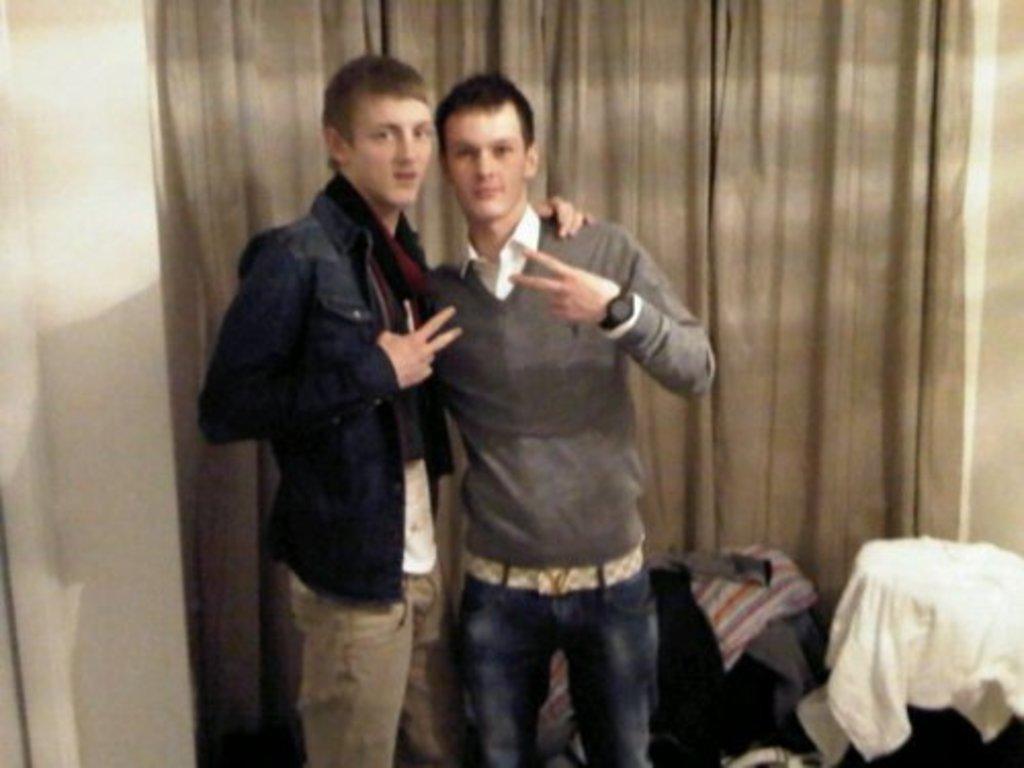In one or two sentences, can you explain what this image depicts? In the background we can see the wall and a curtain. In this picture we can see the men standing and they both are giving a pose. On the right side of the picture we can see the clothes. 